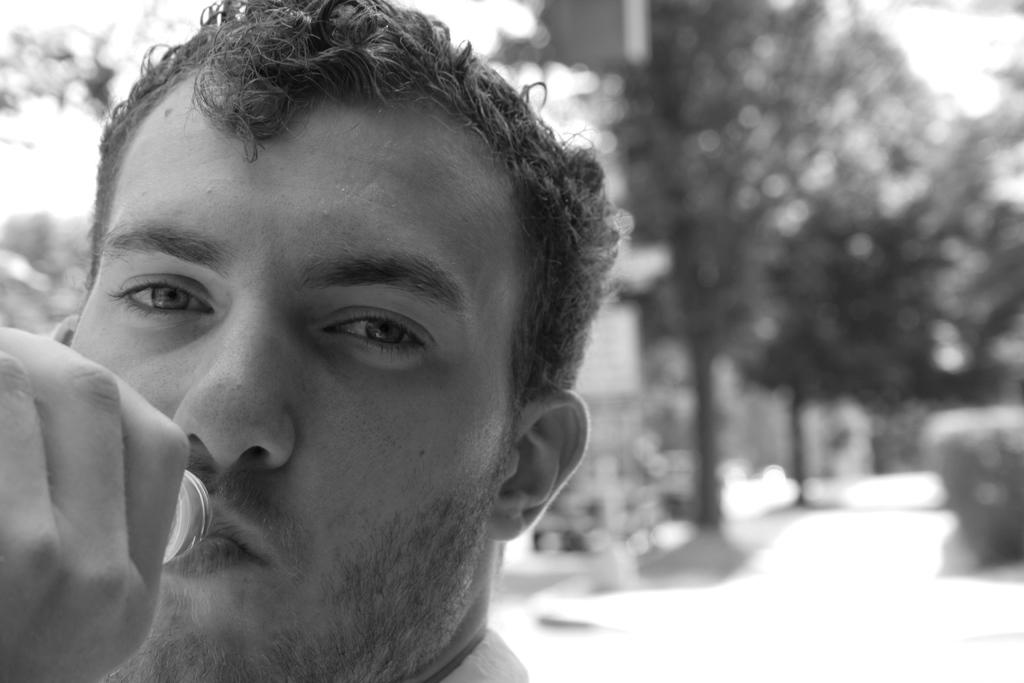What is the color scheme of the image? The image is black and white. Can you describe the person in the image? There is a person in the image. What is the person holding in his hand? The person is holding a bottle with his hand. How would you describe the background of the image? The background of the image is blurred. What is the person's desire for the distance in the image? There is no indication of the person's desire or distance in the image, as it is a black and white image with a blurred background. 